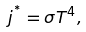Convert formula to latex. <formula><loc_0><loc_0><loc_500><loc_500>j ^ { ^ { * } } = \sigma T ^ { 4 } ,</formula> 